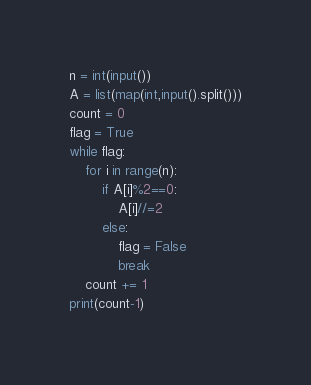Convert code to text. <code><loc_0><loc_0><loc_500><loc_500><_Python_>n = int(input())
A = list(map(int,input().split()))
count = 0
flag = True
while flag:
    for i in range(n):
        if A[i]%2==0:
            A[i]//=2
        else:
            flag = False
            break
    count += 1
print(count-1)
</code> 